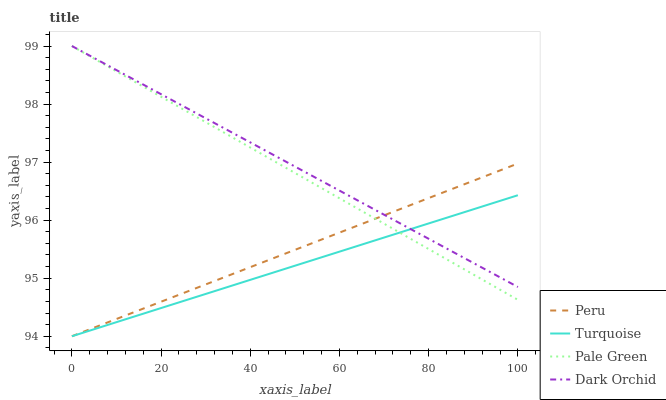Does Turquoise have the minimum area under the curve?
Answer yes or no. Yes. Does Dark Orchid have the maximum area under the curve?
Answer yes or no. Yes. Does Pale Green have the minimum area under the curve?
Answer yes or no. No. Does Pale Green have the maximum area under the curve?
Answer yes or no. No. Is Pale Green the smoothest?
Answer yes or no. Yes. Is Dark Orchid the roughest?
Answer yes or no. Yes. Is Dark Orchid the smoothest?
Answer yes or no. No. Is Pale Green the roughest?
Answer yes or no. No. Does Turquoise have the lowest value?
Answer yes or no. Yes. Does Pale Green have the lowest value?
Answer yes or no. No. Does Dark Orchid have the highest value?
Answer yes or no. Yes. Does Peru have the highest value?
Answer yes or no. No. Does Pale Green intersect Turquoise?
Answer yes or no. Yes. Is Pale Green less than Turquoise?
Answer yes or no. No. Is Pale Green greater than Turquoise?
Answer yes or no. No. 